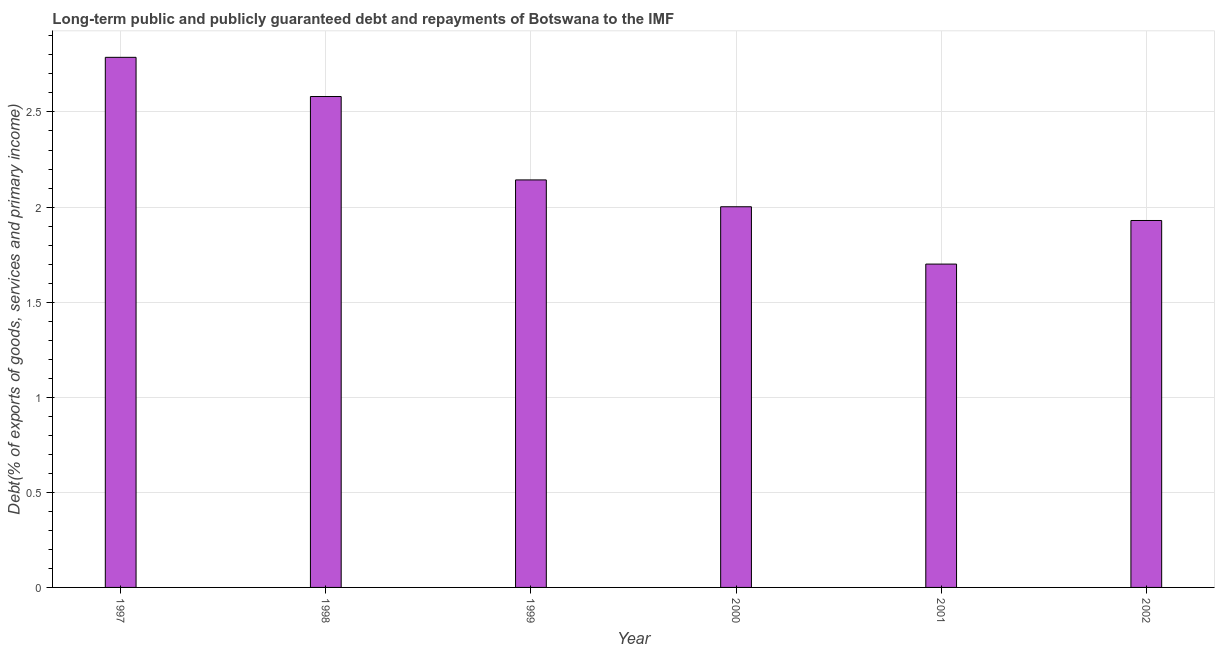What is the title of the graph?
Give a very brief answer. Long-term public and publicly guaranteed debt and repayments of Botswana to the IMF. What is the label or title of the Y-axis?
Offer a terse response. Debt(% of exports of goods, services and primary income). What is the debt service in 2001?
Provide a short and direct response. 1.7. Across all years, what is the maximum debt service?
Offer a very short reply. 2.79. Across all years, what is the minimum debt service?
Keep it short and to the point. 1.7. In which year was the debt service maximum?
Your answer should be very brief. 1997. What is the sum of the debt service?
Ensure brevity in your answer.  13.14. What is the difference between the debt service in 1997 and 2002?
Ensure brevity in your answer.  0.86. What is the average debt service per year?
Keep it short and to the point. 2.19. What is the median debt service?
Your response must be concise. 2.07. What is the ratio of the debt service in 1997 to that in 2002?
Make the answer very short. 1.45. What is the difference between the highest and the second highest debt service?
Offer a terse response. 0.21. What is the difference between the highest and the lowest debt service?
Ensure brevity in your answer.  1.09. How many years are there in the graph?
Ensure brevity in your answer.  6. What is the Debt(% of exports of goods, services and primary income) in 1997?
Ensure brevity in your answer.  2.79. What is the Debt(% of exports of goods, services and primary income) in 1998?
Your answer should be compact. 2.58. What is the Debt(% of exports of goods, services and primary income) of 1999?
Offer a very short reply. 2.14. What is the Debt(% of exports of goods, services and primary income) of 2000?
Your answer should be compact. 2. What is the Debt(% of exports of goods, services and primary income) of 2001?
Keep it short and to the point. 1.7. What is the Debt(% of exports of goods, services and primary income) of 2002?
Offer a terse response. 1.93. What is the difference between the Debt(% of exports of goods, services and primary income) in 1997 and 1998?
Provide a short and direct response. 0.21. What is the difference between the Debt(% of exports of goods, services and primary income) in 1997 and 1999?
Your response must be concise. 0.64. What is the difference between the Debt(% of exports of goods, services and primary income) in 1997 and 2000?
Ensure brevity in your answer.  0.79. What is the difference between the Debt(% of exports of goods, services and primary income) in 1997 and 2001?
Offer a very short reply. 1.09. What is the difference between the Debt(% of exports of goods, services and primary income) in 1997 and 2002?
Keep it short and to the point. 0.86. What is the difference between the Debt(% of exports of goods, services and primary income) in 1998 and 1999?
Provide a short and direct response. 0.44. What is the difference between the Debt(% of exports of goods, services and primary income) in 1998 and 2000?
Give a very brief answer. 0.58. What is the difference between the Debt(% of exports of goods, services and primary income) in 1998 and 2001?
Give a very brief answer. 0.88. What is the difference between the Debt(% of exports of goods, services and primary income) in 1998 and 2002?
Your answer should be compact. 0.65. What is the difference between the Debt(% of exports of goods, services and primary income) in 1999 and 2000?
Make the answer very short. 0.14. What is the difference between the Debt(% of exports of goods, services and primary income) in 1999 and 2001?
Your answer should be compact. 0.44. What is the difference between the Debt(% of exports of goods, services and primary income) in 1999 and 2002?
Keep it short and to the point. 0.21. What is the difference between the Debt(% of exports of goods, services and primary income) in 2000 and 2001?
Ensure brevity in your answer.  0.3. What is the difference between the Debt(% of exports of goods, services and primary income) in 2000 and 2002?
Give a very brief answer. 0.07. What is the difference between the Debt(% of exports of goods, services and primary income) in 2001 and 2002?
Your answer should be very brief. -0.23. What is the ratio of the Debt(% of exports of goods, services and primary income) in 1997 to that in 1998?
Your answer should be compact. 1.08. What is the ratio of the Debt(% of exports of goods, services and primary income) in 1997 to that in 1999?
Provide a short and direct response. 1.3. What is the ratio of the Debt(% of exports of goods, services and primary income) in 1997 to that in 2000?
Ensure brevity in your answer.  1.39. What is the ratio of the Debt(% of exports of goods, services and primary income) in 1997 to that in 2001?
Your answer should be compact. 1.64. What is the ratio of the Debt(% of exports of goods, services and primary income) in 1997 to that in 2002?
Your answer should be compact. 1.45. What is the ratio of the Debt(% of exports of goods, services and primary income) in 1998 to that in 1999?
Make the answer very short. 1.21. What is the ratio of the Debt(% of exports of goods, services and primary income) in 1998 to that in 2000?
Ensure brevity in your answer.  1.29. What is the ratio of the Debt(% of exports of goods, services and primary income) in 1998 to that in 2001?
Provide a short and direct response. 1.52. What is the ratio of the Debt(% of exports of goods, services and primary income) in 1998 to that in 2002?
Offer a very short reply. 1.34. What is the ratio of the Debt(% of exports of goods, services and primary income) in 1999 to that in 2000?
Provide a short and direct response. 1.07. What is the ratio of the Debt(% of exports of goods, services and primary income) in 1999 to that in 2001?
Your answer should be very brief. 1.26. What is the ratio of the Debt(% of exports of goods, services and primary income) in 1999 to that in 2002?
Your answer should be compact. 1.11. What is the ratio of the Debt(% of exports of goods, services and primary income) in 2000 to that in 2001?
Give a very brief answer. 1.18. What is the ratio of the Debt(% of exports of goods, services and primary income) in 2001 to that in 2002?
Offer a terse response. 0.88. 